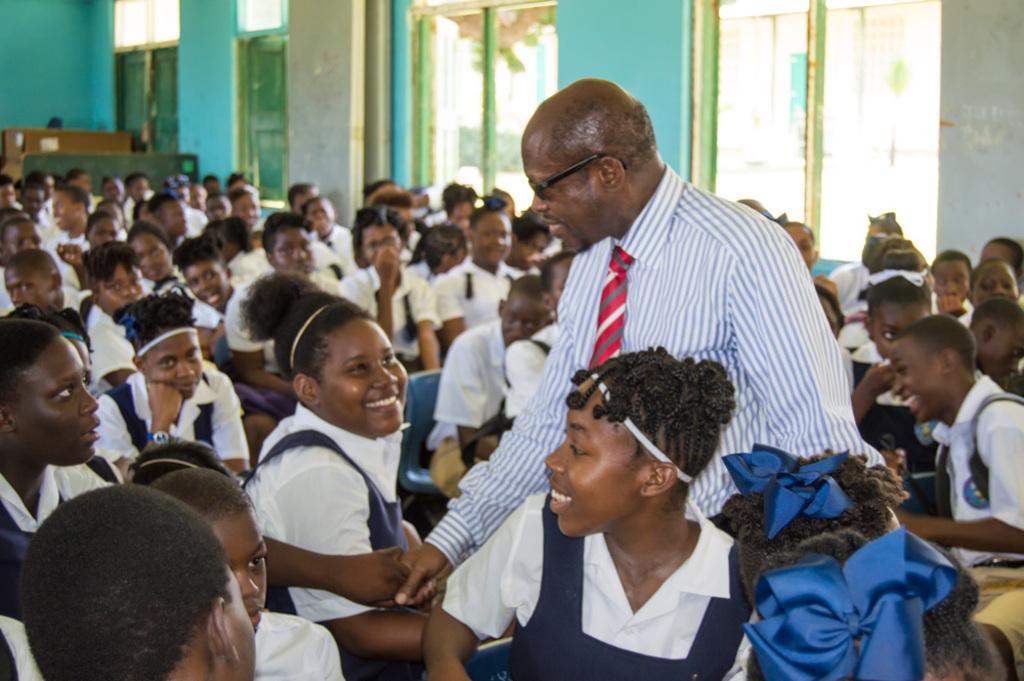Who is present in the image? There are children and a person standing in the image. What are the children doing in the image? The children are sitting in the image. What can be seen in the background of the image? There is a wall in the background of the image. Are there any openings visible in the image? Yes, there are windows visible in the image. What type of hair can be seen on the lawyer in the image? There is no lawyer present in the image, and therefore no hair to describe. How does the person smash the windows in the image? There is no indication in the image that the person is smashing the windows, and therefore no such action can be observed. 